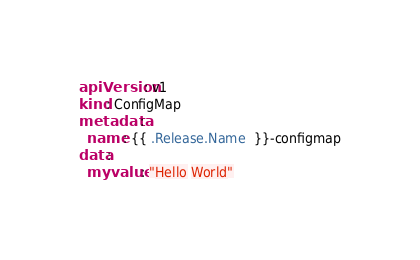Convert code to text. <code><loc_0><loc_0><loc_500><loc_500><_YAML_>apiVersion: v1
kind: ConfigMap
metadata:
  name: {{ .Release.Name  }}-configmap
data:
  myvalue: "Hello World"

</code> 